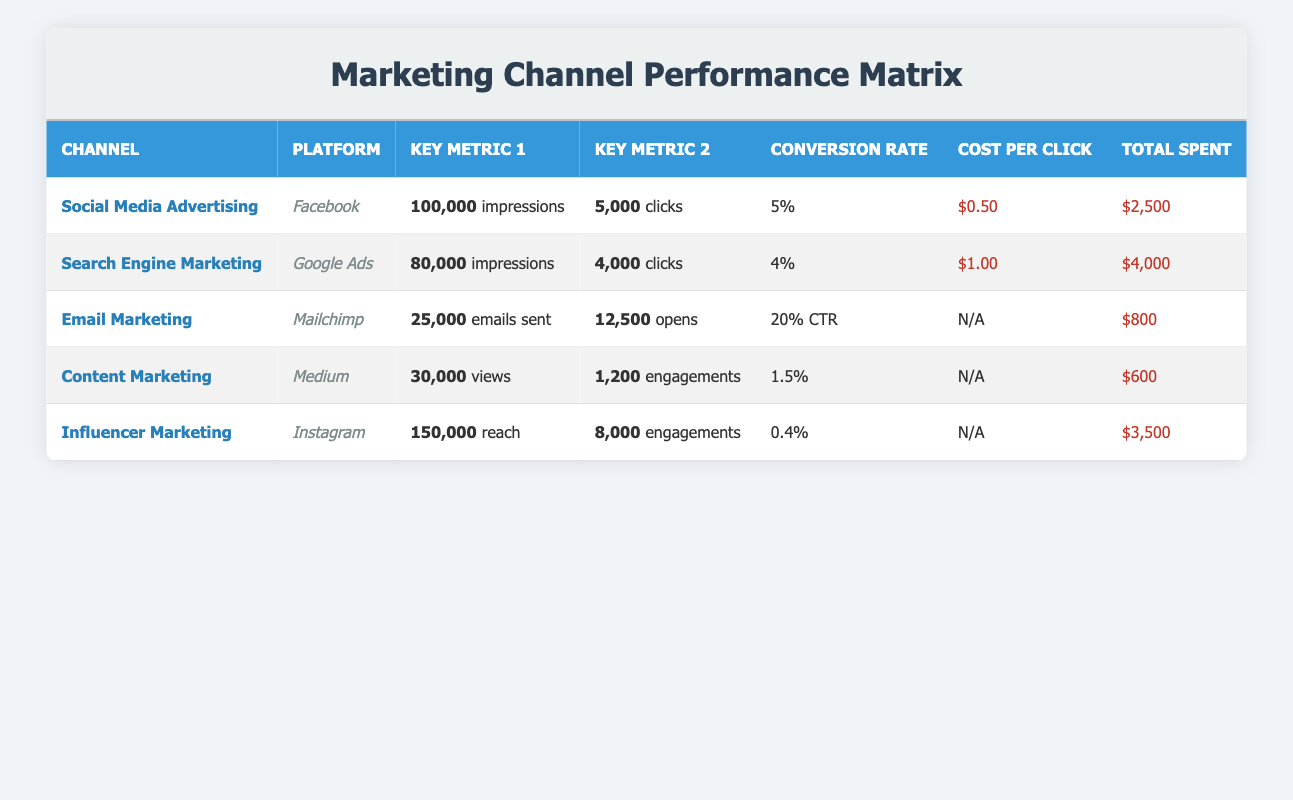What is the total number of clicks from Social Media Advertising? The table indicates that there were 5,000 clicks from Social Media Advertising.
Answer: 5,000 Which marketing channel had the highest total spent? By looking at the total spent figures, Social Media Advertising cost $2,500, Search Engine Marketing cost $4,000, Email Marketing cost $800, Content Marketing cost $600, and Influencer Marketing cost $3,500. Therefore, Search Engine Marketing had the highest total spent at $4,000.
Answer: $4,000 What is the average conversion rate for both Social Media and Search Engine Marketing? Social Media Advertising has a conversion rate of 5%, and Search Engine Marketing has a conversion rate of 4%. To calculate the average, add 5% and 4%, which equals 9%, and then divide by 2, which gives 4.5%.
Answer: 4.5% Did Email Marketing achieve a higher click-through rate than Content Marketing's engagement rate? Email Marketing has a click-through rate of 20%, while Content Marketing's engagement rate is derived from 1,200 engagements out of 30,000 views, resulting in an engagement rate of 4%. Since 20% is greater than 4%, Email Marketing achieved a higher rate.
Answer: Yes What is the total number of impressions across all marketing channels? To find the total impressions, sum the impressions from each channel: 100,000 (Social Media) + 80,000 (Search Engine) + 25,000 (Email) + 30,000 (Content) + 150,000 (Influencer) = 385,000.
Answer: 385,000 Is it true that Content Marketing had the lowest conversion rate? The conversion rate for Content Marketing is 1.5%, while Influencer Marketing has a conversion rate of 0.4%. Since 1.5% is greater than 0.4%, Content Marketing did not have the lowest conversion rate.
Answer: No Which platform had the most reach, and how many engagements did it generate? The Influencer Marketing channel on Instagram had the most reach at 150,000, resulting in 8,000 engagements. Thus, Instagram had the highest engagement figures alongside its reach.
Answer: 8,000 engagements Calculate the total number of emails opened through Email Marketing, and what percentage of those were converted? The table indicates 12,500 emails were opened, and there were 500 conversions. The conversion rate can be calculated as (500 / 12,500) * 100, resulting in a 4% conversion rate. Thus, the total opened emails are 12,500 and the conversion percentage is 4%.
Answer: 12,500 emails opened, 4% conversion rate 